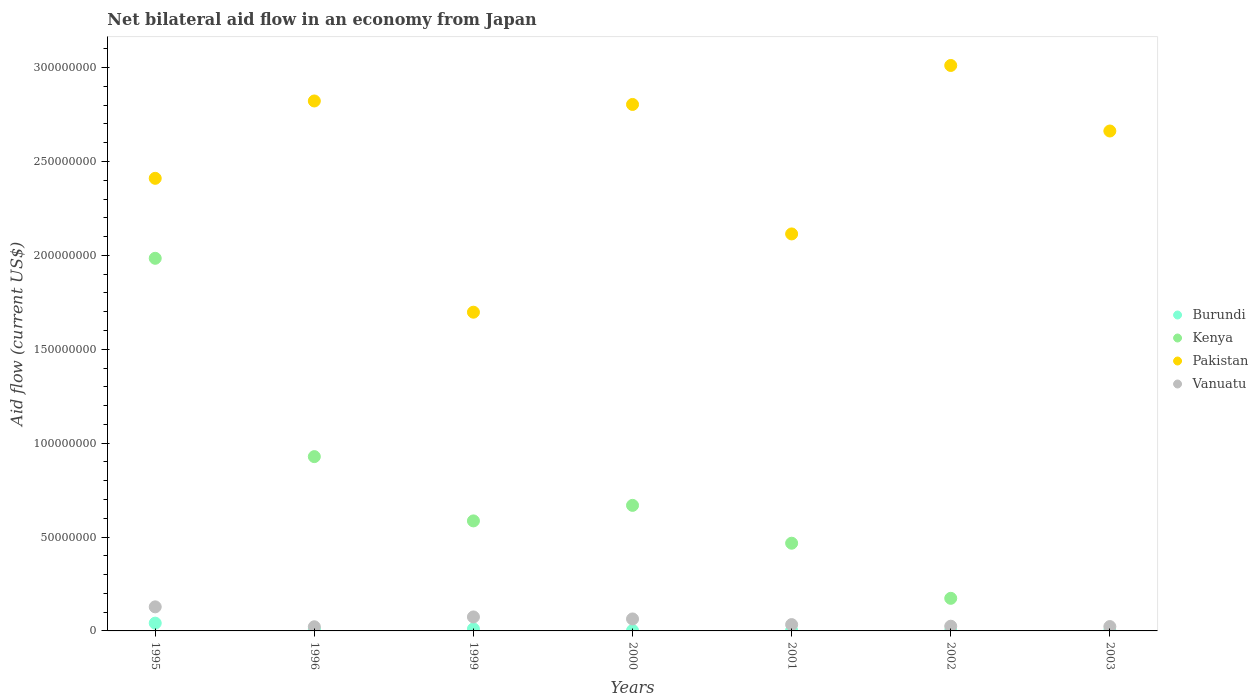How many different coloured dotlines are there?
Your answer should be compact. 4. Is the number of dotlines equal to the number of legend labels?
Ensure brevity in your answer.  No. Across all years, what is the maximum net bilateral aid flow in Kenya?
Your answer should be compact. 1.98e+08. Across all years, what is the minimum net bilateral aid flow in Pakistan?
Offer a terse response. 1.70e+08. What is the total net bilateral aid flow in Burundi in the graph?
Ensure brevity in your answer.  6.92e+06. What is the difference between the net bilateral aid flow in Pakistan in 2002 and that in 2003?
Provide a succinct answer. 3.49e+07. What is the difference between the net bilateral aid flow in Kenya in 2002 and the net bilateral aid flow in Pakistan in 2003?
Make the answer very short. -2.49e+08. What is the average net bilateral aid flow in Vanuatu per year?
Your answer should be compact. 5.29e+06. In the year 1996, what is the difference between the net bilateral aid flow in Pakistan and net bilateral aid flow in Vanuatu?
Make the answer very short. 2.80e+08. What is the ratio of the net bilateral aid flow in Pakistan in 1995 to that in 2001?
Your answer should be very brief. 1.14. Is the net bilateral aid flow in Burundi in 1996 less than that in 2003?
Provide a succinct answer. No. What is the difference between the highest and the second highest net bilateral aid flow in Kenya?
Make the answer very short. 1.06e+08. What is the difference between the highest and the lowest net bilateral aid flow in Burundi?
Offer a terse response. 4.05e+06. Is it the case that in every year, the sum of the net bilateral aid flow in Kenya and net bilateral aid flow in Vanuatu  is greater than the sum of net bilateral aid flow in Burundi and net bilateral aid flow in Pakistan?
Provide a succinct answer. No. Is it the case that in every year, the sum of the net bilateral aid flow in Burundi and net bilateral aid flow in Kenya  is greater than the net bilateral aid flow in Pakistan?
Give a very brief answer. No. Is the net bilateral aid flow in Vanuatu strictly greater than the net bilateral aid flow in Burundi over the years?
Keep it short and to the point. Yes. Is the net bilateral aid flow in Kenya strictly less than the net bilateral aid flow in Pakistan over the years?
Your response must be concise. Yes. How many dotlines are there?
Your answer should be compact. 4. How many years are there in the graph?
Make the answer very short. 7. Are the values on the major ticks of Y-axis written in scientific E-notation?
Your answer should be very brief. No. Does the graph contain grids?
Provide a succinct answer. No. Where does the legend appear in the graph?
Keep it short and to the point. Center right. How many legend labels are there?
Keep it short and to the point. 4. What is the title of the graph?
Your answer should be very brief. Net bilateral aid flow in an economy from Japan. Does "Lesotho" appear as one of the legend labels in the graph?
Make the answer very short. No. What is the label or title of the X-axis?
Your response must be concise. Years. What is the label or title of the Y-axis?
Your answer should be compact. Aid flow (current US$). What is the Aid flow (current US$) in Burundi in 1995?
Give a very brief answer. 4.14e+06. What is the Aid flow (current US$) in Kenya in 1995?
Make the answer very short. 1.98e+08. What is the Aid flow (current US$) of Pakistan in 1995?
Your answer should be very brief. 2.41e+08. What is the Aid flow (current US$) of Vanuatu in 1995?
Your answer should be compact. 1.28e+07. What is the Aid flow (current US$) in Burundi in 1996?
Provide a short and direct response. 1.01e+06. What is the Aid flow (current US$) of Kenya in 1996?
Your answer should be compact. 9.28e+07. What is the Aid flow (current US$) in Pakistan in 1996?
Your answer should be very brief. 2.82e+08. What is the Aid flow (current US$) in Vanuatu in 1996?
Your response must be concise. 2.21e+06. What is the Aid flow (current US$) of Burundi in 1999?
Offer a very short reply. 1.06e+06. What is the Aid flow (current US$) in Kenya in 1999?
Keep it short and to the point. 5.86e+07. What is the Aid flow (current US$) in Pakistan in 1999?
Your answer should be very brief. 1.70e+08. What is the Aid flow (current US$) of Vanuatu in 1999?
Provide a succinct answer. 7.45e+06. What is the Aid flow (current US$) of Burundi in 2000?
Your answer should be very brief. 2.40e+05. What is the Aid flow (current US$) in Kenya in 2000?
Provide a short and direct response. 6.69e+07. What is the Aid flow (current US$) of Pakistan in 2000?
Provide a succinct answer. 2.80e+08. What is the Aid flow (current US$) of Vanuatu in 2000?
Offer a terse response. 6.38e+06. What is the Aid flow (current US$) of Kenya in 2001?
Make the answer very short. 4.67e+07. What is the Aid flow (current US$) in Pakistan in 2001?
Provide a short and direct response. 2.11e+08. What is the Aid flow (current US$) in Vanuatu in 2001?
Provide a succinct answer. 3.37e+06. What is the Aid flow (current US$) in Burundi in 2002?
Your answer should be very brief. 9.00e+04. What is the Aid flow (current US$) of Kenya in 2002?
Provide a short and direct response. 1.74e+07. What is the Aid flow (current US$) in Pakistan in 2002?
Offer a terse response. 3.01e+08. What is the Aid flow (current US$) of Vanuatu in 2002?
Provide a succinct answer. 2.51e+06. What is the Aid flow (current US$) of Burundi in 2003?
Keep it short and to the point. 9.00e+04. What is the Aid flow (current US$) of Pakistan in 2003?
Offer a terse response. 2.66e+08. What is the Aid flow (current US$) of Vanuatu in 2003?
Give a very brief answer. 2.32e+06. Across all years, what is the maximum Aid flow (current US$) of Burundi?
Keep it short and to the point. 4.14e+06. Across all years, what is the maximum Aid flow (current US$) in Kenya?
Give a very brief answer. 1.98e+08. Across all years, what is the maximum Aid flow (current US$) in Pakistan?
Provide a short and direct response. 3.01e+08. Across all years, what is the maximum Aid flow (current US$) of Vanuatu?
Ensure brevity in your answer.  1.28e+07. Across all years, what is the minimum Aid flow (current US$) in Kenya?
Provide a succinct answer. 0. Across all years, what is the minimum Aid flow (current US$) in Pakistan?
Give a very brief answer. 1.70e+08. Across all years, what is the minimum Aid flow (current US$) in Vanuatu?
Provide a short and direct response. 2.21e+06. What is the total Aid flow (current US$) in Burundi in the graph?
Give a very brief answer. 6.92e+06. What is the total Aid flow (current US$) in Kenya in the graph?
Keep it short and to the point. 4.81e+08. What is the total Aid flow (current US$) in Pakistan in the graph?
Your answer should be compact. 1.75e+09. What is the total Aid flow (current US$) of Vanuatu in the graph?
Your answer should be compact. 3.71e+07. What is the difference between the Aid flow (current US$) in Burundi in 1995 and that in 1996?
Give a very brief answer. 3.13e+06. What is the difference between the Aid flow (current US$) in Kenya in 1995 and that in 1996?
Provide a succinct answer. 1.06e+08. What is the difference between the Aid flow (current US$) in Pakistan in 1995 and that in 1996?
Provide a succinct answer. -4.12e+07. What is the difference between the Aid flow (current US$) of Vanuatu in 1995 and that in 1996?
Make the answer very short. 1.06e+07. What is the difference between the Aid flow (current US$) of Burundi in 1995 and that in 1999?
Your answer should be compact. 3.08e+06. What is the difference between the Aid flow (current US$) of Kenya in 1995 and that in 1999?
Provide a short and direct response. 1.40e+08. What is the difference between the Aid flow (current US$) of Pakistan in 1995 and that in 1999?
Provide a succinct answer. 7.13e+07. What is the difference between the Aid flow (current US$) in Vanuatu in 1995 and that in 1999?
Offer a very short reply. 5.37e+06. What is the difference between the Aid flow (current US$) in Burundi in 1995 and that in 2000?
Your answer should be very brief. 3.90e+06. What is the difference between the Aid flow (current US$) in Kenya in 1995 and that in 2000?
Offer a terse response. 1.32e+08. What is the difference between the Aid flow (current US$) of Pakistan in 1995 and that in 2000?
Your answer should be very brief. -3.93e+07. What is the difference between the Aid flow (current US$) of Vanuatu in 1995 and that in 2000?
Give a very brief answer. 6.44e+06. What is the difference between the Aid flow (current US$) in Burundi in 1995 and that in 2001?
Your answer should be very brief. 3.85e+06. What is the difference between the Aid flow (current US$) in Kenya in 1995 and that in 2001?
Provide a short and direct response. 1.52e+08. What is the difference between the Aid flow (current US$) of Pakistan in 1995 and that in 2001?
Make the answer very short. 2.96e+07. What is the difference between the Aid flow (current US$) of Vanuatu in 1995 and that in 2001?
Your response must be concise. 9.45e+06. What is the difference between the Aid flow (current US$) in Burundi in 1995 and that in 2002?
Ensure brevity in your answer.  4.05e+06. What is the difference between the Aid flow (current US$) in Kenya in 1995 and that in 2002?
Offer a terse response. 1.81e+08. What is the difference between the Aid flow (current US$) in Pakistan in 1995 and that in 2002?
Make the answer very short. -6.01e+07. What is the difference between the Aid flow (current US$) in Vanuatu in 1995 and that in 2002?
Your answer should be compact. 1.03e+07. What is the difference between the Aid flow (current US$) in Burundi in 1995 and that in 2003?
Your response must be concise. 4.05e+06. What is the difference between the Aid flow (current US$) in Pakistan in 1995 and that in 2003?
Offer a very short reply. -2.52e+07. What is the difference between the Aid flow (current US$) in Vanuatu in 1995 and that in 2003?
Your answer should be compact. 1.05e+07. What is the difference between the Aid flow (current US$) of Burundi in 1996 and that in 1999?
Keep it short and to the point. -5.00e+04. What is the difference between the Aid flow (current US$) of Kenya in 1996 and that in 1999?
Give a very brief answer. 3.42e+07. What is the difference between the Aid flow (current US$) of Pakistan in 1996 and that in 1999?
Your response must be concise. 1.12e+08. What is the difference between the Aid flow (current US$) of Vanuatu in 1996 and that in 1999?
Provide a short and direct response. -5.24e+06. What is the difference between the Aid flow (current US$) in Burundi in 1996 and that in 2000?
Give a very brief answer. 7.70e+05. What is the difference between the Aid flow (current US$) of Kenya in 1996 and that in 2000?
Give a very brief answer. 2.60e+07. What is the difference between the Aid flow (current US$) in Pakistan in 1996 and that in 2000?
Your response must be concise. 1.85e+06. What is the difference between the Aid flow (current US$) of Vanuatu in 1996 and that in 2000?
Offer a very short reply. -4.17e+06. What is the difference between the Aid flow (current US$) of Burundi in 1996 and that in 2001?
Give a very brief answer. 7.20e+05. What is the difference between the Aid flow (current US$) of Kenya in 1996 and that in 2001?
Provide a succinct answer. 4.61e+07. What is the difference between the Aid flow (current US$) of Pakistan in 1996 and that in 2001?
Your response must be concise. 7.08e+07. What is the difference between the Aid flow (current US$) of Vanuatu in 1996 and that in 2001?
Your answer should be very brief. -1.16e+06. What is the difference between the Aid flow (current US$) in Burundi in 1996 and that in 2002?
Provide a succinct answer. 9.20e+05. What is the difference between the Aid flow (current US$) of Kenya in 1996 and that in 2002?
Ensure brevity in your answer.  7.55e+07. What is the difference between the Aid flow (current US$) in Pakistan in 1996 and that in 2002?
Give a very brief answer. -1.89e+07. What is the difference between the Aid flow (current US$) of Vanuatu in 1996 and that in 2002?
Provide a short and direct response. -3.00e+05. What is the difference between the Aid flow (current US$) in Burundi in 1996 and that in 2003?
Your answer should be compact. 9.20e+05. What is the difference between the Aid flow (current US$) of Pakistan in 1996 and that in 2003?
Your response must be concise. 1.60e+07. What is the difference between the Aid flow (current US$) in Vanuatu in 1996 and that in 2003?
Offer a terse response. -1.10e+05. What is the difference between the Aid flow (current US$) in Burundi in 1999 and that in 2000?
Ensure brevity in your answer.  8.20e+05. What is the difference between the Aid flow (current US$) of Kenya in 1999 and that in 2000?
Offer a very short reply. -8.27e+06. What is the difference between the Aid flow (current US$) of Pakistan in 1999 and that in 2000?
Give a very brief answer. -1.11e+08. What is the difference between the Aid flow (current US$) of Vanuatu in 1999 and that in 2000?
Give a very brief answer. 1.07e+06. What is the difference between the Aid flow (current US$) in Burundi in 1999 and that in 2001?
Ensure brevity in your answer.  7.70e+05. What is the difference between the Aid flow (current US$) of Kenya in 1999 and that in 2001?
Keep it short and to the point. 1.19e+07. What is the difference between the Aid flow (current US$) of Pakistan in 1999 and that in 2001?
Make the answer very short. -4.17e+07. What is the difference between the Aid flow (current US$) in Vanuatu in 1999 and that in 2001?
Provide a short and direct response. 4.08e+06. What is the difference between the Aid flow (current US$) in Burundi in 1999 and that in 2002?
Your answer should be compact. 9.70e+05. What is the difference between the Aid flow (current US$) in Kenya in 1999 and that in 2002?
Offer a terse response. 4.12e+07. What is the difference between the Aid flow (current US$) of Pakistan in 1999 and that in 2002?
Offer a terse response. -1.31e+08. What is the difference between the Aid flow (current US$) in Vanuatu in 1999 and that in 2002?
Give a very brief answer. 4.94e+06. What is the difference between the Aid flow (current US$) of Burundi in 1999 and that in 2003?
Ensure brevity in your answer.  9.70e+05. What is the difference between the Aid flow (current US$) of Pakistan in 1999 and that in 2003?
Provide a succinct answer. -9.65e+07. What is the difference between the Aid flow (current US$) in Vanuatu in 1999 and that in 2003?
Give a very brief answer. 5.13e+06. What is the difference between the Aid flow (current US$) of Kenya in 2000 and that in 2001?
Provide a succinct answer. 2.02e+07. What is the difference between the Aid flow (current US$) of Pakistan in 2000 and that in 2001?
Give a very brief answer. 6.90e+07. What is the difference between the Aid flow (current US$) of Vanuatu in 2000 and that in 2001?
Provide a succinct answer. 3.01e+06. What is the difference between the Aid flow (current US$) of Burundi in 2000 and that in 2002?
Give a very brief answer. 1.50e+05. What is the difference between the Aid flow (current US$) in Kenya in 2000 and that in 2002?
Ensure brevity in your answer.  4.95e+07. What is the difference between the Aid flow (current US$) in Pakistan in 2000 and that in 2002?
Your answer should be very brief. -2.08e+07. What is the difference between the Aid flow (current US$) in Vanuatu in 2000 and that in 2002?
Provide a short and direct response. 3.87e+06. What is the difference between the Aid flow (current US$) of Burundi in 2000 and that in 2003?
Your response must be concise. 1.50e+05. What is the difference between the Aid flow (current US$) in Pakistan in 2000 and that in 2003?
Your response must be concise. 1.41e+07. What is the difference between the Aid flow (current US$) of Vanuatu in 2000 and that in 2003?
Make the answer very short. 4.06e+06. What is the difference between the Aid flow (current US$) in Kenya in 2001 and that in 2002?
Your answer should be compact. 2.94e+07. What is the difference between the Aid flow (current US$) in Pakistan in 2001 and that in 2002?
Ensure brevity in your answer.  -8.97e+07. What is the difference between the Aid flow (current US$) of Vanuatu in 2001 and that in 2002?
Your response must be concise. 8.60e+05. What is the difference between the Aid flow (current US$) in Burundi in 2001 and that in 2003?
Keep it short and to the point. 2.00e+05. What is the difference between the Aid flow (current US$) in Pakistan in 2001 and that in 2003?
Make the answer very short. -5.48e+07. What is the difference between the Aid flow (current US$) of Vanuatu in 2001 and that in 2003?
Your response must be concise. 1.05e+06. What is the difference between the Aid flow (current US$) in Burundi in 2002 and that in 2003?
Offer a terse response. 0. What is the difference between the Aid flow (current US$) in Pakistan in 2002 and that in 2003?
Provide a short and direct response. 3.49e+07. What is the difference between the Aid flow (current US$) in Vanuatu in 2002 and that in 2003?
Your answer should be compact. 1.90e+05. What is the difference between the Aid flow (current US$) of Burundi in 1995 and the Aid flow (current US$) of Kenya in 1996?
Your response must be concise. -8.87e+07. What is the difference between the Aid flow (current US$) of Burundi in 1995 and the Aid flow (current US$) of Pakistan in 1996?
Your answer should be compact. -2.78e+08. What is the difference between the Aid flow (current US$) of Burundi in 1995 and the Aid flow (current US$) of Vanuatu in 1996?
Keep it short and to the point. 1.93e+06. What is the difference between the Aid flow (current US$) in Kenya in 1995 and the Aid flow (current US$) in Pakistan in 1996?
Keep it short and to the point. -8.38e+07. What is the difference between the Aid flow (current US$) in Kenya in 1995 and the Aid flow (current US$) in Vanuatu in 1996?
Offer a very short reply. 1.96e+08. What is the difference between the Aid flow (current US$) in Pakistan in 1995 and the Aid flow (current US$) in Vanuatu in 1996?
Provide a short and direct response. 2.39e+08. What is the difference between the Aid flow (current US$) of Burundi in 1995 and the Aid flow (current US$) of Kenya in 1999?
Your answer should be compact. -5.44e+07. What is the difference between the Aid flow (current US$) of Burundi in 1995 and the Aid flow (current US$) of Pakistan in 1999?
Your response must be concise. -1.66e+08. What is the difference between the Aid flow (current US$) in Burundi in 1995 and the Aid flow (current US$) in Vanuatu in 1999?
Your answer should be very brief. -3.31e+06. What is the difference between the Aid flow (current US$) in Kenya in 1995 and the Aid flow (current US$) in Pakistan in 1999?
Provide a short and direct response. 2.87e+07. What is the difference between the Aid flow (current US$) in Kenya in 1995 and the Aid flow (current US$) in Vanuatu in 1999?
Make the answer very short. 1.91e+08. What is the difference between the Aid flow (current US$) of Pakistan in 1995 and the Aid flow (current US$) of Vanuatu in 1999?
Make the answer very short. 2.34e+08. What is the difference between the Aid flow (current US$) in Burundi in 1995 and the Aid flow (current US$) in Kenya in 2000?
Ensure brevity in your answer.  -6.27e+07. What is the difference between the Aid flow (current US$) in Burundi in 1995 and the Aid flow (current US$) in Pakistan in 2000?
Give a very brief answer. -2.76e+08. What is the difference between the Aid flow (current US$) in Burundi in 1995 and the Aid flow (current US$) in Vanuatu in 2000?
Offer a terse response. -2.24e+06. What is the difference between the Aid flow (current US$) in Kenya in 1995 and the Aid flow (current US$) in Pakistan in 2000?
Offer a very short reply. -8.19e+07. What is the difference between the Aid flow (current US$) in Kenya in 1995 and the Aid flow (current US$) in Vanuatu in 2000?
Keep it short and to the point. 1.92e+08. What is the difference between the Aid flow (current US$) of Pakistan in 1995 and the Aid flow (current US$) of Vanuatu in 2000?
Offer a terse response. 2.35e+08. What is the difference between the Aid flow (current US$) in Burundi in 1995 and the Aid flow (current US$) in Kenya in 2001?
Provide a succinct answer. -4.26e+07. What is the difference between the Aid flow (current US$) in Burundi in 1995 and the Aid flow (current US$) in Pakistan in 2001?
Your answer should be very brief. -2.07e+08. What is the difference between the Aid flow (current US$) in Burundi in 1995 and the Aid flow (current US$) in Vanuatu in 2001?
Your answer should be very brief. 7.70e+05. What is the difference between the Aid flow (current US$) of Kenya in 1995 and the Aid flow (current US$) of Pakistan in 2001?
Provide a succinct answer. -1.30e+07. What is the difference between the Aid flow (current US$) in Kenya in 1995 and the Aid flow (current US$) in Vanuatu in 2001?
Give a very brief answer. 1.95e+08. What is the difference between the Aid flow (current US$) of Pakistan in 1995 and the Aid flow (current US$) of Vanuatu in 2001?
Offer a very short reply. 2.38e+08. What is the difference between the Aid flow (current US$) in Burundi in 1995 and the Aid flow (current US$) in Kenya in 2002?
Your answer should be very brief. -1.32e+07. What is the difference between the Aid flow (current US$) in Burundi in 1995 and the Aid flow (current US$) in Pakistan in 2002?
Offer a terse response. -2.97e+08. What is the difference between the Aid flow (current US$) in Burundi in 1995 and the Aid flow (current US$) in Vanuatu in 2002?
Make the answer very short. 1.63e+06. What is the difference between the Aid flow (current US$) of Kenya in 1995 and the Aid flow (current US$) of Pakistan in 2002?
Ensure brevity in your answer.  -1.03e+08. What is the difference between the Aid flow (current US$) in Kenya in 1995 and the Aid flow (current US$) in Vanuatu in 2002?
Ensure brevity in your answer.  1.96e+08. What is the difference between the Aid flow (current US$) in Pakistan in 1995 and the Aid flow (current US$) in Vanuatu in 2002?
Your answer should be very brief. 2.39e+08. What is the difference between the Aid flow (current US$) of Burundi in 1995 and the Aid flow (current US$) of Pakistan in 2003?
Provide a succinct answer. -2.62e+08. What is the difference between the Aid flow (current US$) of Burundi in 1995 and the Aid flow (current US$) of Vanuatu in 2003?
Your response must be concise. 1.82e+06. What is the difference between the Aid flow (current US$) in Kenya in 1995 and the Aid flow (current US$) in Pakistan in 2003?
Provide a succinct answer. -6.78e+07. What is the difference between the Aid flow (current US$) in Kenya in 1995 and the Aid flow (current US$) in Vanuatu in 2003?
Your response must be concise. 1.96e+08. What is the difference between the Aid flow (current US$) of Pakistan in 1995 and the Aid flow (current US$) of Vanuatu in 2003?
Your answer should be compact. 2.39e+08. What is the difference between the Aid flow (current US$) of Burundi in 1996 and the Aid flow (current US$) of Kenya in 1999?
Keep it short and to the point. -5.76e+07. What is the difference between the Aid flow (current US$) in Burundi in 1996 and the Aid flow (current US$) in Pakistan in 1999?
Keep it short and to the point. -1.69e+08. What is the difference between the Aid flow (current US$) of Burundi in 1996 and the Aid flow (current US$) of Vanuatu in 1999?
Offer a terse response. -6.44e+06. What is the difference between the Aid flow (current US$) of Kenya in 1996 and the Aid flow (current US$) of Pakistan in 1999?
Ensure brevity in your answer.  -7.69e+07. What is the difference between the Aid flow (current US$) of Kenya in 1996 and the Aid flow (current US$) of Vanuatu in 1999?
Keep it short and to the point. 8.54e+07. What is the difference between the Aid flow (current US$) of Pakistan in 1996 and the Aid flow (current US$) of Vanuatu in 1999?
Your answer should be very brief. 2.75e+08. What is the difference between the Aid flow (current US$) of Burundi in 1996 and the Aid flow (current US$) of Kenya in 2000?
Offer a very short reply. -6.58e+07. What is the difference between the Aid flow (current US$) in Burundi in 1996 and the Aid flow (current US$) in Pakistan in 2000?
Make the answer very short. -2.79e+08. What is the difference between the Aid flow (current US$) in Burundi in 1996 and the Aid flow (current US$) in Vanuatu in 2000?
Offer a very short reply. -5.37e+06. What is the difference between the Aid flow (current US$) of Kenya in 1996 and the Aid flow (current US$) of Pakistan in 2000?
Provide a short and direct response. -1.88e+08. What is the difference between the Aid flow (current US$) in Kenya in 1996 and the Aid flow (current US$) in Vanuatu in 2000?
Your answer should be very brief. 8.64e+07. What is the difference between the Aid flow (current US$) in Pakistan in 1996 and the Aid flow (current US$) in Vanuatu in 2000?
Offer a terse response. 2.76e+08. What is the difference between the Aid flow (current US$) of Burundi in 1996 and the Aid flow (current US$) of Kenya in 2001?
Your response must be concise. -4.57e+07. What is the difference between the Aid flow (current US$) in Burundi in 1996 and the Aid flow (current US$) in Pakistan in 2001?
Keep it short and to the point. -2.10e+08. What is the difference between the Aid flow (current US$) in Burundi in 1996 and the Aid flow (current US$) in Vanuatu in 2001?
Keep it short and to the point. -2.36e+06. What is the difference between the Aid flow (current US$) of Kenya in 1996 and the Aid flow (current US$) of Pakistan in 2001?
Make the answer very short. -1.19e+08. What is the difference between the Aid flow (current US$) of Kenya in 1996 and the Aid flow (current US$) of Vanuatu in 2001?
Provide a short and direct response. 8.94e+07. What is the difference between the Aid flow (current US$) in Pakistan in 1996 and the Aid flow (current US$) in Vanuatu in 2001?
Provide a succinct answer. 2.79e+08. What is the difference between the Aid flow (current US$) in Burundi in 1996 and the Aid flow (current US$) in Kenya in 2002?
Provide a short and direct response. -1.64e+07. What is the difference between the Aid flow (current US$) in Burundi in 1996 and the Aid flow (current US$) in Pakistan in 2002?
Provide a succinct answer. -3.00e+08. What is the difference between the Aid flow (current US$) of Burundi in 1996 and the Aid flow (current US$) of Vanuatu in 2002?
Offer a very short reply. -1.50e+06. What is the difference between the Aid flow (current US$) in Kenya in 1996 and the Aid flow (current US$) in Pakistan in 2002?
Make the answer very short. -2.08e+08. What is the difference between the Aid flow (current US$) in Kenya in 1996 and the Aid flow (current US$) in Vanuatu in 2002?
Your answer should be very brief. 9.03e+07. What is the difference between the Aid flow (current US$) of Pakistan in 1996 and the Aid flow (current US$) of Vanuatu in 2002?
Offer a very short reply. 2.80e+08. What is the difference between the Aid flow (current US$) of Burundi in 1996 and the Aid flow (current US$) of Pakistan in 2003?
Offer a very short reply. -2.65e+08. What is the difference between the Aid flow (current US$) of Burundi in 1996 and the Aid flow (current US$) of Vanuatu in 2003?
Make the answer very short. -1.31e+06. What is the difference between the Aid flow (current US$) of Kenya in 1996 and the Aid flow (current US$) of Pakistan in 2003?
Make the answer very short. -1.73e+08. What is the difference between the Aid flow (current US$) of Kenya in 1996 and the Aid flow (current US$) of Vanuatu in 2003?
Your response must be concise. 9.05e+07. What is the difference between the Aid flow (current US$) of Pakistan in 1996 and the Aid flow (current US$) of Vanuatu in 2003?
Make the answer very short. 2.80e+08. What is the difference between the Aid flow (current US$) of Burundi in 1999 and the Aid flow (current US$) of Kenya in 2000?
Provide a short and direct response. -6.58e+07. What is the difference between the Aid flow (current US$) of Burundi in 1999 and the Aid flow (current US$) of Pakistan in 2000?
Your response must be concise. -2.79e+08. What is the difference between the Aid flow (current US$) in Burundi in 1999 and the Aid flow (current US$) in Vanuatu in 2000?
Ensure brevity in your answer.  -5.32e+06. What is the difference between the Aid flow (current US$) in Kenya in 1999 and the Aid flow (current US$) in Pakistan in 2000?
Your response must be concise. -2.22e+08. What is the difference between the Aid flow (current US$) of Kenya in 1999 and the Aid flow (current US$) of Vanuatu in 2000?
Offer a terse response. 5.22e+07. What is the difference between the Aid flow (current US$) in Pakistan in 1999 and the Aid flow (current US$) in Vanuatu in 2000?
Give a very brief answer. 1.63e+08. What is the difference between the Aid flow (current US$) in Burundi in 1999 and the Aid flow (current US$) in Kenya in 2001?
Your answer should be very brief. -4.56e+07. What is the difference between the Aid flow (current US$) in Burundi in 1999 and the Aid flow (current US$) in Pakistan in 2001?
Your answer should be compact. -2.10e+08. What is the difference between the Aid flow (current US$) in Burundi in 1999 and the Aid flow (current US$) in Vanuatu in 2001?
Provide a short and direct response. -2.31e+06. What is the difference between the Aid flow (current US$) in Kenya in 1999 and the Aid flow (current US$) in Pakistan in 2001?
Your answer should be very brief. -1.53e+08. What is the difference between the Aid flow (current US$) of Kenya in 1999 and the Aid flow (current US$) of Vanuatu in 2001?
Make the answer very short. 5.52e+07. What is the difference between the Aid flow (current US$) of Pakistan in 1999 and the Aid flow (current US$) of Vanuatu in 2001?
Your answer should be compact. 1.66e+08. What is the difference between the Aid flow (current US$) of Burundi in 1999 and the Aid flow (current US$) of Kenya in 2002?
Give a very brief answer. -1.63e+07. What is the difference between the Aid flow (current US$) in Burundi in 1999 and the Aid flow (current US$) in Pakistan in 2002?
Give a very brief answer. -3.00e+08. What is the difference between the Aid flow (current US$) of Burundi in 1999 and the Aid flow (current US$) of Vanuatu in 2002?
Provide a succinct answer. -1.45e+06. What is the difference between the Aid flow (current US$) of Kenya in 1999 and the Aid flow (current US$) of Pakistan in 2002?
Provide a succinct answer. -2.43e+08. What is the difference between the Aid flow (current US$) of Kenya in 1999 and the Aid flow (current US$) of Vanuatu in 2002?
Your response must be concise. 5.61e+07. What is the difference between the Aid flow (current US$) in Pakistan in 1999 and the Aid flow (current US$) in Vanuatu in 2002?
Your answer should be very brief. 1.67e+08. What is the difference between the Aid flow (current US$) in Burundi in 1999 and the Aid flow (current US$) in Pakistan in 2003?
Your response must be concise. -2.65e+08. What is the difference between the Aid flow (current US$) of Burundi in 1999 and the Aid flow (current US$) of Vanuatu in 2003?
Your answer should be compact. -1.26e+06. What is the difference between the Aid flow (current US$) in Kenya in 1999 and the Aid flow (current US$) in Pakistan in 2003?
Ensure brevity in your answer.  -2.08e+08. What is the difference between the Aid flow (current US$) in Kenya in 1999 and the Aid flow (current US$) in Vanuatu in 2003?
Provide a short and direct response. 5.63e+07. What is the difference between the Aid flow (current US$) in Pakistan in 1999 and the Aid flow (current US$) in Vanuatu in 2003?
Offer a terse response. 1.67e+08. What is the difference between the Aid flow (current US$) of Burundi in 2000 and the Aid flow (current US$) of Kenya in 2001?
Your answer should be very brief. -4.65e+07. What is the difference between the Aid flow (current US$) in Burundi in 2000 and the Aid flow (current US$) in Pakistan in 2001?
Keep it short and to the point. -2.11e+08. What is the difference between the Aid flow (current US$) of Burundi in 2000 and the Aid flow (current US$) of Vanuatu in 2001?
Your answer should be compact. -3.13e+06. What is the difference between the Aid flow (current US$) in Kenya in 2000 and the Aid flow (current US$) in Pakistan in 2001?
Offer a terse response. -1.45e+08. What is the difference between the Aid flow (current US$) of Kenya in 2000 and the Aid flow (current US$) of Vanuatu in 2001?
Your answer should be very brief. 6.35e+07. What is the difference between the Aid flow (current US$) in Pakistan in 2000 and the Aid flow (current US$) in Vanuatu in 2001?
Keep it short and to the point. 2.77e+08. What is the difference between the Aid flow (current US$) in Burundi in 2000 and the Aid flow (current US$) in Kenya in 2002?
Your answer should be very brief. -1.71e+07. What is the difference between the Aid flow (current US$) of Burundi in 2000 and the Aid flow (current US$) of Pakistan in 2002?
Ensure brevity in your answer.  -3.01e+08. What is the difference between the Aid flow (current US$) of Burundi in 2000 and the Aid flow (current US$) of Vanuatu in 2002?
Ensure brevity in your answer.  -2.27e+06. What is the difference between the Aid flow (current US$) of Kenya in 2000 and the Aid flow (current US$) of Pakistan in 2002?
Make the answer very short. -2.34e+08. What is the difference between the Aid flow (current US$) in Kenya in 2000 and the Aid flow (current US$) in Vanuatu in 2002?
Your response must be concise. 6.44e+07. What is the difference between the Aid flow (current US$) in Pakistan in 2000 and the Aid flow (current US$) in Vanuatu in 2002?
Provide a succinct answer. 2.78e+08. What is the difference between the Aid flow (current US$) of Burundi in 2000 and the Aid flow (current US$) of Pakistan in 2003?
Your answer should be very brief. -2.66e+08. What is the difference between the Aid flow (current US$) of Burundi in 2000 and the Aid flow (current US$) of Vanuatu in 2003?
Offer a terse response. -2.08e+06. What is the difference between the Aid flow (current US$) of Kenya in 2000 and the Aid flow (current US$) of Pakistan in 2003?
Your answer should be compact. -1.99e+08. What is the difference between the Aid flow (current US$) of Kenya in 2000 and the Aid flow (current US$) of Vanuatu in 2003?
Your answer should be very brief. 6.45e+07. What is the difference between the Aid flow (current US$) in Pakistan in 2000 and the Aid flow (current US$) in Vanuatu in 2003?
Offer a terse response. 2.78e+08. What is the difference between the Aid flow (current US$) in Burundi in 2001 and the Aid flow (current US$) in Kenya in 2002?
Your answer should be compact. -1.71e+07. What is the difference between the Aid flow (current US$) in Burundi in 2001 and the Aid flow (current US$) in Pakistan in 2002?
Offer a very short reply. -3.01e+08. What is the difference between the Aid flow (current US$) of Burundi in 2001 and the Aid flow (current US$) of Vanuatu in 2002?
Offer a very short reply. -2.22e+06. What is the difference between the Aid flow (current US$) of Kenya in 2001 and the Aid flow (current US$) of Pakistan in 2002?
Ensure brevity in your answer.  -2.54e+08. What is the difference between the Aid flow (current US$) in Kenya in 2001 and the Aid flow (current US$) in Vanuatu in 2002?
Give a very brief answer. 4.42e+07. What is the difference between the Aid flow (current US$) in Pakistan in 2001 and the Aid flow (current US$) in Vanuatu in 2002?
Offer a terse response. 2.09e+08. What is the difference between the Aid flow (current US$) in Burundi in 2001 and the Aid flow (current US$) in Pakistan in 2003?
Provide a succinct answer. -2.66e+08. What is the difference between the Aid flow (current US$) of Burundi in 2001 and the Aid flow (current US$) of Vanuatu in 2003?
Keep it short and to the point. -2.03e+06. What is the difference between the Aid flow (current US$) of Kenya in 2001 and the Aid flow (current US$) of Pakistan in 2003?
Offer a very short reply. -2.20e+08. What is the difference between the Aid flow (current US$) in Kenya in 2001 and the Aid flow (current US$) in Vanuatu in 2003?
Make the answer very short. 4.44e+07. What is the difference between the Aid flow (current US$) of Pakistan in 2001 and the Aid flow (current US$) of Vanuatu in 2003?
Your answer should be very brief. 2.09e+08. What is the difference between the Aid flow (current US$) in Burundi in 2002 and the Aid flow (current US$) in Pakistan in 2003?
Ensure brevity in your answer.  -2.66e+08. What is the difference between the Aid flow (current US$) in Burundi in 2002 and the Aid flow (current US$) in Vanuatu in 2003?
Make the answer very short. -2.23e+06. What is the difference between the Aid flow (current US$) in Kenya in 2002 and the Aid flow (current US$) in Pakistan in 2003?
Provide a short and direct response. -2.49e+08. What is the difference between the Aid flow (current US$) of Kenya in 2002 and the Aid flow (current US$) of Vanuatu in 2003?
Ensure brevity in your answer.  1.50e+07. What is the difference between the Aid flow (current US$) of Pakistan in 2002 and the Aid flow (current US$) of Vanuatu in 2003?
Keep it short and to the point. 2.99e+08. What is the average Aid flow (current US$) in Burundi per year?
Keep it short and to the point. 9.89e+05. What is the average Aid flow (current US$) of Kenya per year?
Your answer should be compact. 6.87e+07. What is the average Aid flow (current US$) in Pakistan per year?
Your answer should be compact. 2.50e+08. What is the average Aid flow (current US$) in Vanuatu per year?
Your answer should be very brief. 5.29e+06. In the year 1995, what is the difference between the Aid flow (current US$) in Burundi and Aid flow (current US$) in Kenya?
Your response must be concise. -1.94e+08. In the year 1995, what is the difference between the Aid flow (current US$) of Burundi and Aid flow (current US$) of Pakistan?
Provide a short and direct response. -2.37e+08. In the year 1995, what is the difference between the Aid flow (current US$) of Burundi and Aid flow (current US$) of Vanuatu?
Keep it short and to the point. -8.68e+06. In the year 1995, what is the difference between the Aid flow (current US$) of Kenya and Aid flow (current US$) of Pakistan?
Your answer should be very brief. -4.26e+07. In the year 1995, what is the difference between the Aid flow (current US$) of Kenya and Aid flow (current US$) of Vanuatu?
Keep it short and to the point. 1.86e+08. In the year 1995, what is the difference between the Aid flow (current US$) in Pakistan and Aid flow (current US$) in Vanuatu?
Give a very brief answer. 2.28e+08. In the year 1996, what is the difference between the Aid flow (current US$) in Burundi and Aid flow (current US$) in Kenya?
Offer a terse response. -9.18e+07. In the year 1996, what is the difference between the Aid flow (current US$) of Burundi and Aid flow (current US$) of Pakistan?
Give a very brief answer. -2.81e+08. In the year 1996, what is the difference between the Aid flow (current US$) in Burundi and Aid flow (current US$) in Vanuatu?
Offer a very short reply. -1.20e+06. In the year 1996, what is the difference between the Aid flow (current US$) of Kenya and Aid flow (current US$) of Pakistan?
Give a very brief answer. -1.89e+08. In the year 1996, what is the difference between the Aid flow (current US$) in Kenya and Aid flow (current US$) in Vanuatu?
Keep it short and to the point. 9.06e+07. In the year 1996, what is the difference between the Aid flow (current US$) of Pakistan and Aid flow (current US$) of Vanuatu?
Give a very brief answer. 2.80e+08. In the year 1999, what is the difference between the Aid flow (current US$) in Burundi and Aid flow (current US$) in Kenya?
Offer a very short reply. -5.75e+07. In the year 1999, what is the difference between the Aid flow (current US$) in Burundi and Aid flow (current US$) in Pakistan?
Make the answer very short. -1.69e+08. In the year 1999, what is the difference between the Aid flow (current US$) in Burundi and Aid flow (current US$) in Vanuatu?
Your answer should be very brief. -6.39e+06. In the year 1999, what is the difference between the Aid flow (current US$) in Kenya and Aid flow (current US$) in Pakistan?
Give a very brief answer. -1.11e+08. In the year 1999, what is the difference between the Aid flow (current US$) in Kenya and Aid flow (current US$) in Vanuatu?
Ensure brevity in your answer.  5.11e+07. In the year 1999, what is the difference between the Aid flow (current US$) in Pakistan and Aid flow (current US$) in Vanuatu?
Make the answer very short. 1.62e+08. In the year 2000, what is the difference between the Aid flow (current US$) of Burundi and Aid flow (current US$) of Kenya?
Provide a succinct answer. -6.66e+07. In the year 2000, what is the difference between the Aid flow (current US$) in Burundi and Aid flow (current US$) in Pakistan?
Ensure brevity in your answer.  -2.80e+08. In the year 2000, what is the difference between the Aid flow (current US$) in Burundi and Aid flow (current US$) in Vanuatu?
Your answer should be compact. -6.14e+06. In the year 2000, what is the difference between the Aid flow (current US$) of Kenya and Aid flow (current US$) of Pakistan?
Provide a succinct answer. -2.14e+08. In the year 2000, what is the difference between the Aid flow (current US$) in Kenya and Aid flow (current US$) in Vanuatu?
Provide a succinct answer. 6.05e+07. In the year 2000, what is the difference between the Aid flow (current US$) of Pakistan and Aid flow (current US$) of Vanuatu?
Your response must be concise. 2.74e+08. In the year 2001, what is the difference between the Aid flow (current US$) in Burundi and Aid flow (current US$) in Kenya?
Your response must be concise. -4.64e+07. In the year 2001, what is the difference between the Aid flow (current US$) in Burundi and Aid flow (current US$) in Pakistan?
Your response must be concise. -2.11e+08. In the year 2001, what is the difference between the Aid flow (current US$) in Burundi and Aid flow (current US$) in Vanuatu?
Your response must be concise. -3.08e+06. In the year 2001, what is the difference between the Aid flow (current US$) in Kenya and Aid flow (current US$) in Pakistan?
Your answer should be compact. -1.65e+08. In the year 2001, what is the difference between the Aid flow (current US$) of Kenya and Aid flow (current US$) of Vanuatu?
Your answer should be compact. 4.33e+07. In the year 2001, what is the difference between the Aid flow (current US$) of Pakistan and Aid flow (current US$) of Vanuatu?
Provide a succinct answer. 2.08e+08. In the year 2002, what is the difference between the Aid flow (current US$) in Burundi and Aid flow (current US$) in Kenya?
Your response must be concise. -1.73e+07. In the year 2002, what is the difference between the Aid flow (current US$) in Burundi and Aid flow (current US$) in Pakistan?
Offer a terse response. -3.01e+08. In the year 2002, what is the difference between the Aid flow (current US$) of Burundi and Aid flow (current US$) of Vanuatu?
Offer a very short reply. -2.42e+06. In the year 2002, what is the difference between the Aid flow (current US$) in Kenya and Aid flow (current US$) in Pakistan?
Offer a terse response. -2.84e+08. In the year 2002, what is the difference between the Aid flow (current US$) in Kenya and Aid flow (current US$) in Vanuatu?
Provide a short and direct response. 1.48e+07. In the year 2002, what is the difference between the Aid flow (current US$) in Pakistan and Aid flow (current US$) in Vanuatu?
Your answer should be compact. 2.99e+08. In the year 2003, what is the difference between the Aid flow (current US$) in Burundi and Aid flow (current US$) in Pakistan?
Your response must be concise. -2.66e+08. In the year 2003, what is the difference between the Aid flow (current US$) of Burundi and Aid flow (current US$) of Vanuatu?
Give a very brief answer. -2.23e+06. In the year 2003, what is the difference between the Aid flow (current US$) of Pakistan and Aid flow (current US$) of Vanuatu?
Ensure brevity in your answer.  2.64e+08. What is the ratio of the Aid flow (current US$) in Burundi in 1995 to that in 1996?
Your response must be concise. 4.1. What is the ratio of the Aid flow (current US$) in Kenya in 1995 to that in 1996?
Your response must be concise. 2.14. What is the ratio of the Aid flow (current US$) in Pakistan in 1995 to that in 1996?
Keep it short and to the point. 0.85. What is the ratio of the Aid flow (current US$) of Vanuatu in 1995 to that in 1996?
Give a very brief answer. 5.8. What is the ratio of the Aid flow (current US$) in Burundi in 1995 to that in 1999?
Your response must be concise. 3.91. What is the ratio of the Aid flow (current US$) of Kenya in 1995 to that in 1999?
Offer a terse response. 3.39. What is the ratio of the Aid flow (current US$) in Pakistan in 1995 to that in 1999?
Make the answer very short. 1.42. What is the ratio of the Aid flow (current US$) of Vanuatu in 1995 to that in 1999?
Offer a terse response. 1.72. What is the ratio of the Aid flow (current US$) in Burundi in 1995 to that in 2000?
Offer a very short reply. 17.25. What is the ratio of the Aid flow (current US$) of Kenya in 1995 to that in 2000?
Your answer should be compact. 2.97. What is the ratio of the Aid flow (current US$) of Pakistan in 1995 to that in 2000?
Ensure brevity in your answer.  0.86. What is the ratio of the Aid flow (current US$) in Vanuatu in 1995 to that in 2000?
Your response must be concise. 2.01. What is the ratio of the Aid flow (current US$) in Burundi in 1995 to that in 2001?
Keep it short and to the point. 14.28. What is the ratio of the Aid flow (current US$) in Kenya in 1995 to that in 2001?
Ensure brevity in your answer.  4.25. What is the ratio of the Aid flow (current US$) in Pakistan in 1995 to that in 2001?
Make the answer very short. 1.14. What is the ratio of the Aid flow (current US$) of Vanuatu in 1995 to that in 2001?
Keep it short and to the point. 3.8. What is the ratio of the Aid flow (current US$) in Kenya in 1995 to that in 2002?
Your response must be concise. 11.43. What is the ratio of the Aid flow (current US$) of Pakistan in 1995 to that in 2002?
Your answer should be compact. 0.8. What is the ratio of the Aid flow (current US$) of Vanuatu in 1995 to that in 2002?
Keep it short and to the point. 5.11. What is the ratio of the Aid flow (current US$) in Burundi in 1995 to that in 2003?
Your response must be concise. 46. What is the ratio of the Aid flow (current US$) of Pakistan in 1995 to that in 2003?
Give a very brief answer. 0.91. What is the ratio of the Aid flow (current US$) of Vanuatu in 1995 to that in 2003?
Keep it short and to the point. 5.53. What is the ratio of the Aid flow (current US$) in Burundi in 1996 to that in 1999?
Provide a succinct answer. 0.95. What is the ratio of the Aid flow (current US$) in Kenya in 1996 to that in 1999?
Provide a succinct answer. 1.58. What is the ratio of the Aid flow (current US$) in Pakistan in 1996 to that in 1999?
Provide a short and direct response. 1.66. What is the ratio of the Aid flow (current US$) in Vanuatu in 1996 to that in 1999?
Your answer should be compact. 0.3. What is the ratio of the Aid flow (current US$) in Burundi in 1996 to that in 2000?
Keep it short and to the point. 4.21. What is the ratio of the Aid flow (current US$) in Kenya in 1996 to that in 2000?
Offer a terse response. 1.39. What is the ratio of the Aid flow (current US$) of Pakistan in 1996 to that in 2000?
Keep it short and to the point. 1.01. What is the ratio of the Aid flow (current US$) of Vanuatu in 1996 to that in 2000?
Provide a short and direct response. 0.35. What is the ratio of the Aid flow (current US$) of Burundi in 1996 to that in 2001?
Ensure brevity in your answer.  3.48. What is the ratio of the Aid flow (current US$) in Kenya in 1996 to that in 2001?
Make the answer very short. 1.99. What is the ratio of the Aid flow (current US$) in Pakistan in 1996 to that in 2001?
Provide a short and direct response. 1.33. What is the ratio of the Aid flow (current US$) in Vanuatu in 1996 to that in 2001?
Give a very brief answer. 0.66. What is the ratio of the Aid flow (current US$) of Burundi in 1996 to that in 2002?
Keep it short and to the point. 11.22. What is the ratio of the Aid flow (current US$) in Kenya in 1996 to that in 2002?
Keep it short and to the point. 5.35. What is the ratio of the Aid flow (current US$) of Pakistan in 1996 to that in 2002?
Your answer should be very brief. 0.94. What is the ratio of the Aid flow (current US$) in Vanuatu in 1996 to that in 2002?
Your answer should be compact. 0.88. What is the ratio of the Aid flow (current US$) in Burundi in 1996 to that in 2003?
Offer a terse response. 11.22. What is the ratio of the Aid flow (current US$) of Pakistan in 1996 to that in 2003?
Ensure brevity in your answer.  1.06. What is the ratio of the Aid flow (current US$) in Vanuatu in 1996 to that in 2003?
Provide a succinct answer. 0.95. What is the ratio of the Aid flow (current US$) of Burundi in 1999 to that in 2000?
Give a very brief answer. 4.42. What is the ratio of the Aid flow (current US$) of Kenya in 1999 to that in 2000?
Keep it short and to the point. 0.88. What is the ratio of the Aid flow (current US$) in Pakistan in 1999 to that in 2000?
Give a very brief answer. 0.61. What is the ratio of the Aid flow (current US$) of Vanuatu in 1999 to that in 2000?
Give a very brief answer. 1.17. What is the ratio of the Aid flow (current US$) of Burundi in 1999 to that in 2001?
Make the answer very short. 3.66. What is the ratio of the Aid flow (current US$) in Kenya in 1999 to that in 2001?
Provide a succinct answer. 1.25. What is the ratio of the Aid flow (current US$) in Pakistan in 1999 to that in 2001?
Provide a succinct answer. 0.8. What is the ratio of the Aid flow (current US$) of Vanuatu in 1999 to that in 2001?
Provide a succinct answer. 2.21. What is the ratio of the Aid flow (current US$) of Burundi in 1999 to that in 2002?
Your answer should be very brief. 11.78. What is the ratio of the Aid flow (current US$) in Kenya in 1999 to that in 2002?
Provide a succinct answer. 3.38. What is the ratio of the Aid flow (current US$) of Pakistan in 1999 to that in 2002?
Offer a very short reply. 0.56. What is the ratio of the Aid flow (current US$) in Vanuatu in 1999 to that in 2002?
Your response must be concise. 2.97. What is the ratio of the Aid flow (current US$) of Burundi in 1999 to that in 2003?
Offer a very short reply. 11.78. What is the ratio of the Aid flow (current US$) of Pakistan in 1999 to that in 2003?
Offer a very short reply. 0.64. What is the ratio of the Aid flow (current US$) of Vanuatu in 1999 to that in 2003?
Your answer should be very brief. 3.21. What is the ratio of the Aid flow (current US$) in Burundi in 2000 to that in 2001?
Provide a short and direct response. 0.83. What is the ratio of the Aid flow (current US$) of Kenya in 2000 to that in 2001?
Provide a short and direct response. 1.43. What is the ratio of the Aid flow (current US$) of Pakistan in 2000 to that in 2001?
Give a very brief answer. 1.33. What is the ratio of the Aid flow (current US$) of Vanuatu in 2000 to that in 2001?
Offer a very short reply. 1.89. What is the ratio of the Aid flow (current US$) in Burundi in 2000 to that in 2002?
Your answer should be very brief. 2.67. What is the ratio of the Aid flow (current US$) of Kenya in 2000 to that in 2002?
Keep it short and to the point. 3.85. What is the ratio of the Aid flow (current US$) of Pakistan in 2000 to that in 2002?
Make the answer very short. 0.93. What is the ratio of the Aid flow (current US$) in Vanuatu in 2000 to that in 2002?
Your answer should be very brief. 2.54. What is the ratio of the Aid flow (current US$) in Burundi in 2000 to that in 2003?
Give a very brief answer. 2.67. What is the ratio of the Aid flow (current US$) of Pakistan in 2000 to that in 2003?
Your response must be concise. 1.05. What is the ratio of the Aid flow (current US$) of Vanuatu in 2000 to that in 2003?
Offer a terse response. 2.75. What is the ratio of the Aid flow (current US$) of Burundi in 2001 to that in 2002?
Offer a terse response. 3.22. What is the ratio of the Aid flow (current US$) in Kenya in 2001 to that in 2002?
Give a very brief answer. 2.69. What is the ratio of the Aid flow (current US$) of Pakistan in 2001 to that in 2002?
Offer a terse response. 0.7. What is the ratio of the Aid flow (current US$) of Vanuatu in 2001 to that in 2002?
Provide a short and direct response. 1.34. What is the ratio of the Aid flow (current US$) in Burundi in 2001 to that in 2003?
Give a very brief answer. 3.22. What is the ratio of the Aid flow (current US$) of Pakistan in 2001 to that in 2003?
Keep it short and to the point. 0.79. What is the ratio of the Aid flow (current US$) in Vanuatu in 2001 to that in 2003?
Your answer should be very brief. 1.45. What is the ratio of the Aid flow (current US$) of Pakistan in 2002 to that in 2003?
Offer a very short reply. 1.13. What is the ratio of the Aid flow (current US$) in Vanuatu in 2002 to that in 2003?
Ensure brevity in your answer.  1.08. What is the difference between the highest and the second highest Aid flow (current US$) in Burundi?
Make the answer very short. 3.08e+06. What is the difference between the highest and the second highest Aid flow (current US$) of Kenya?
Your response must be concise. 1.06e+08. What is the difference between the highest and the second highest Aid flow (current US$) in Pakistan?
Give a very brief answer. 1.89e+07. What is the difference between the highest and the second highest Aid flow (current US$) of Vanuatu?
Your answer should be very brief. 5.37e+06. What is the difference between the highest and the lowest Aid flow (current US$) in Burundi?
Your answer should be very brief. 4.05e+06. What is the difference between the highest and the lowest Aid flow (current US$) of Kenya?
Ensure brevity in your answer.  1.98e+08. What is the difference between the highest and the lowest Aid flow (current US$) in Pakistan?
Offer a terse response. 1.31e+08. What is the difference between the highest and the lowest Aid flow (current US$) of Vanuatu?
Offer a terse response. 1.06e+07. 